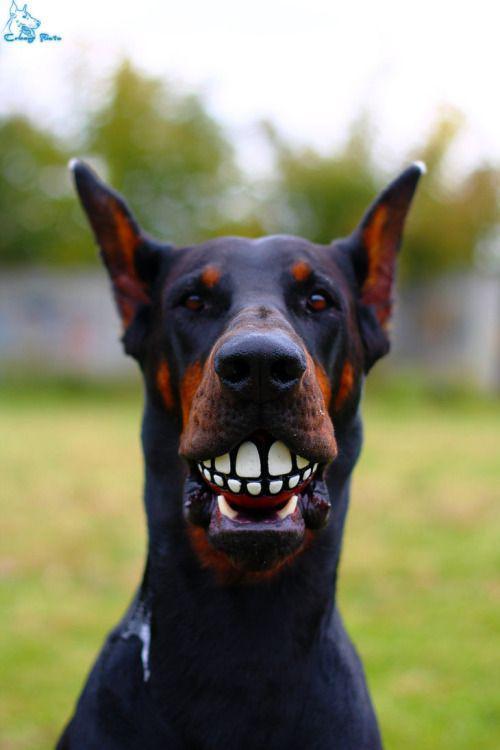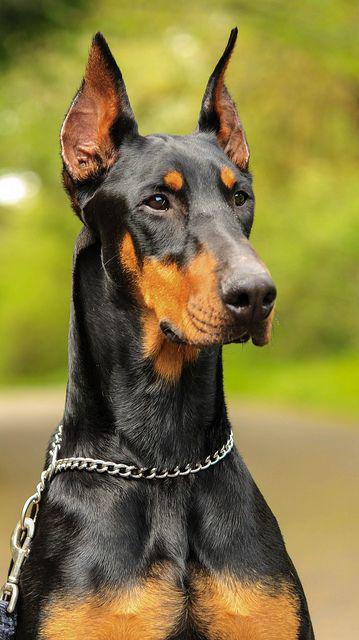The first image is the image on the left, the second image is the image on the right. Given the left and right images, does the statement "Each image contains one dog, and one of the dogs depicted wears a chain collar, while the other dog has something held in its mouth." hold true? Answer yes or no. Yes. The first image is the image on the left, the second image is the image on the right. Assess this claim about the two images: "A single dog in the grass is showing its tongue in the image on the left.". Correct or not? Answer yes or no. No. 